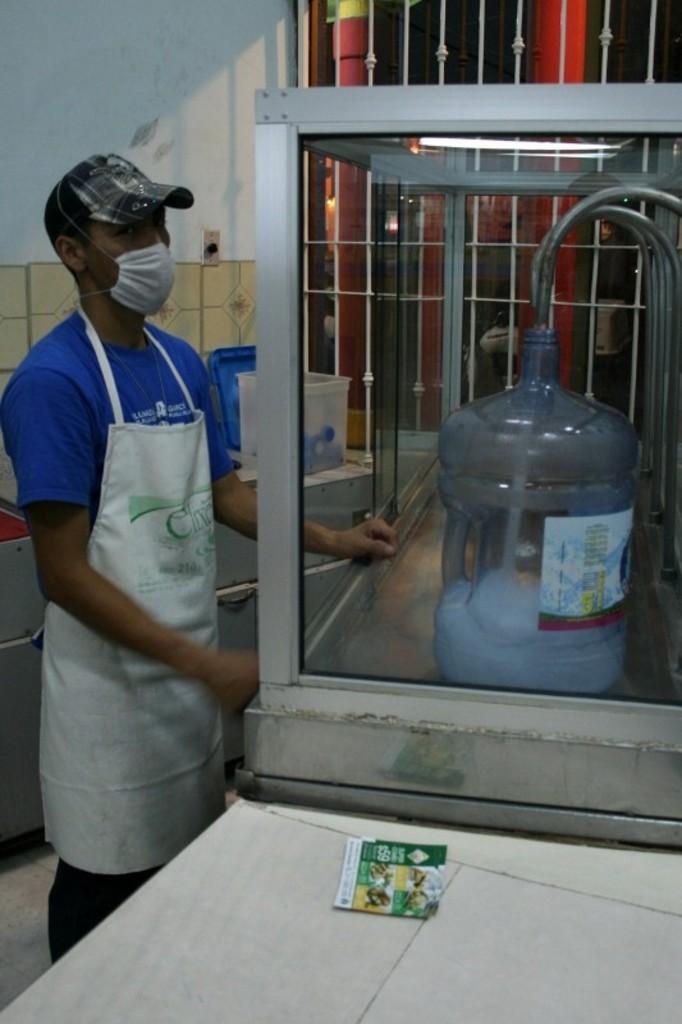How would you summarize this image in a sentence or two? There is a man standing on the floor. He wore a cap and an apron. This is a table. Here we can see a glass box, light, water can, taps, and a box. In the background we can see wall. 